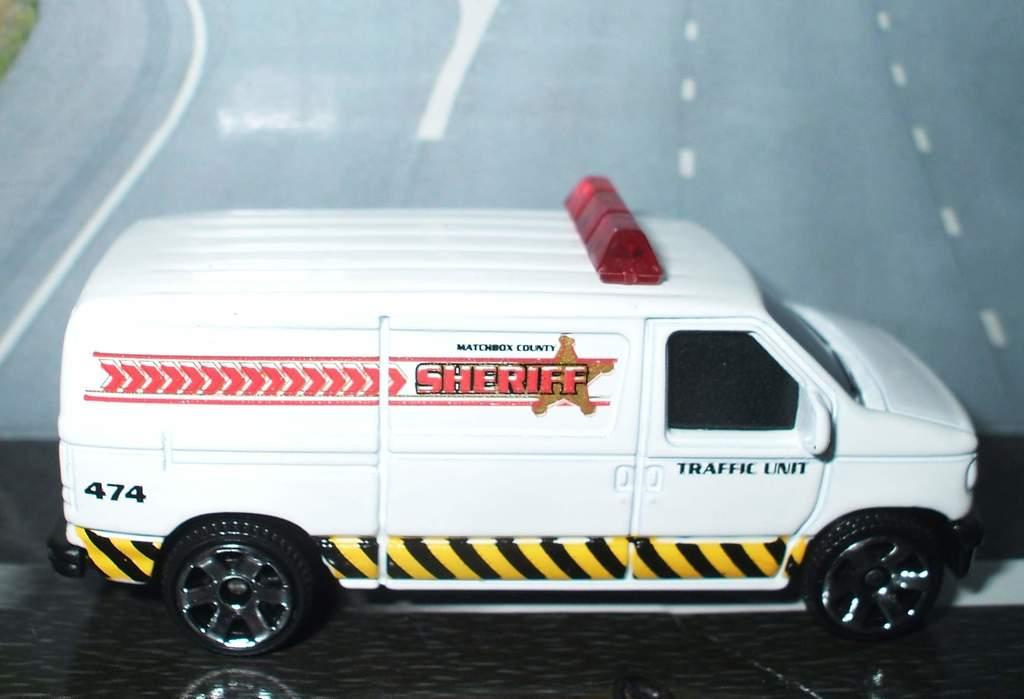<image>
Render a clear and concise summary of the photo. A white toy van says Sheriff traffic unit on the side. 